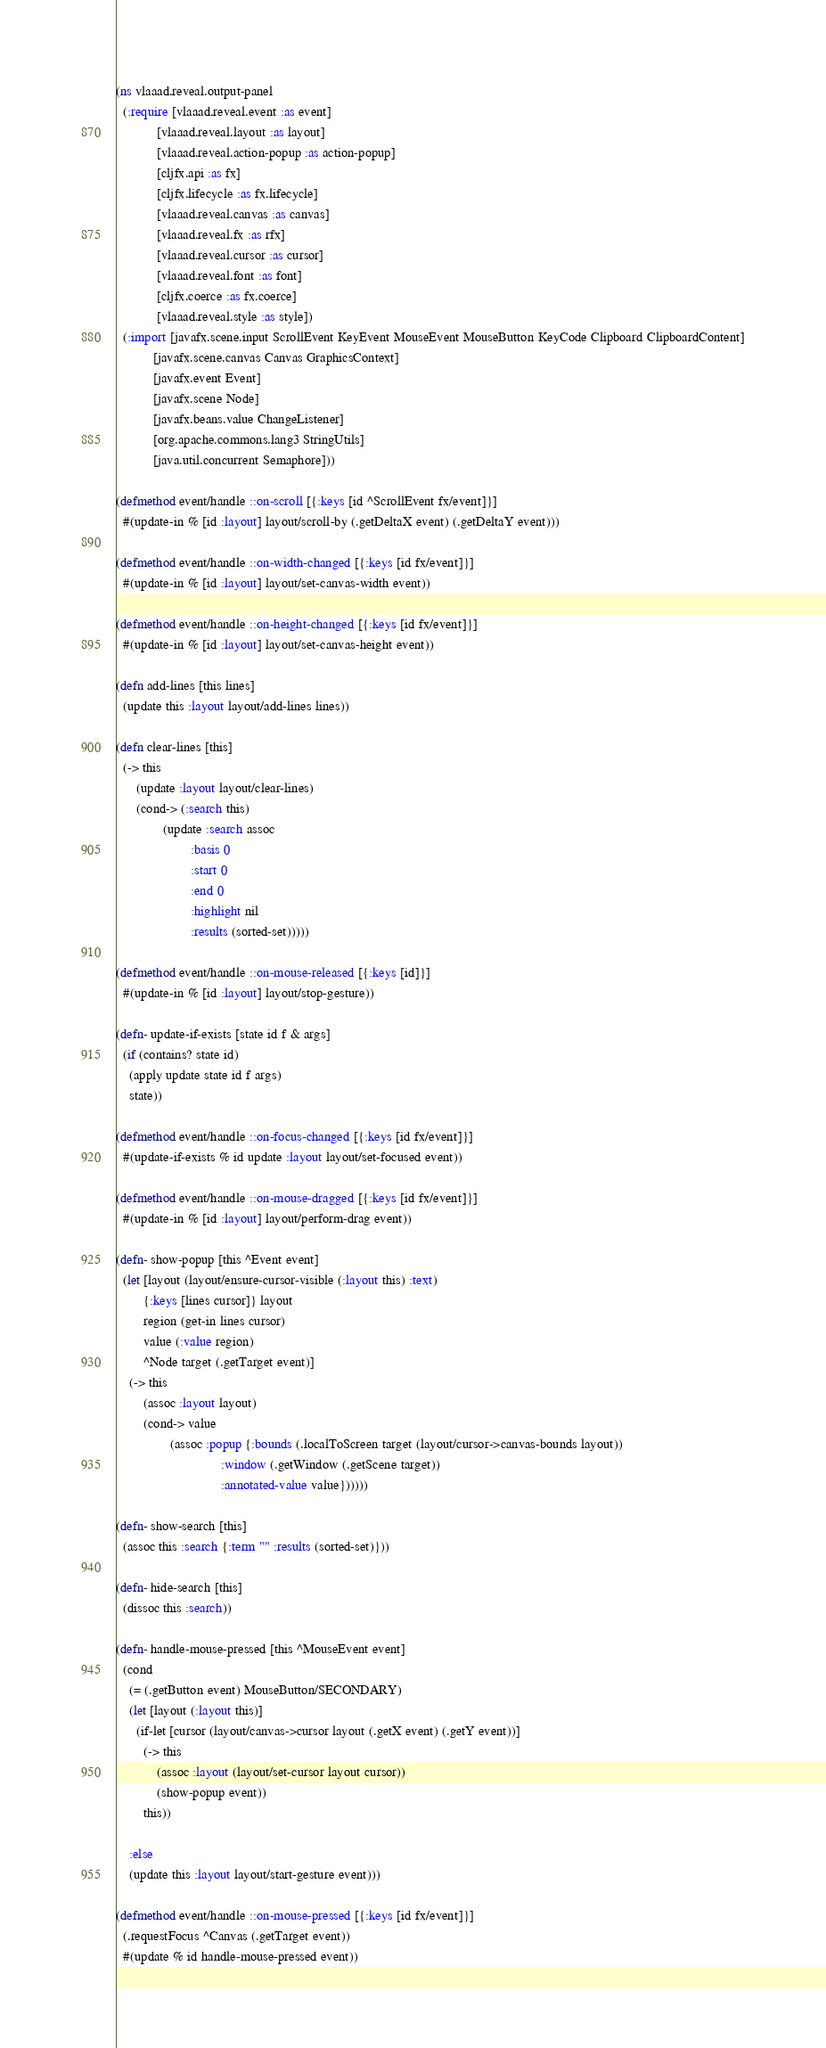Convert code to text. <code><loc_0><loc_0><loc_500><loc_500><_Clojure_>(ns vlaaad.reveal.output-panel
  (:require [vlaaad.reveal.event :as event]
            [vlaaad.reveal.layout :as layout]
            [vlaaad.reveal.action-popup :as action-popup]
            [cljfx.api :as fx]
            [cljfx.lifecycle :as fx.lifecycle]
            [vlaaad.reveal.canvas :as canvas]
            [vlaaad.reveal.fx :as rfx]
            [vlaaad.reveal.cursor :as cursor]
            [vlaaad.reveal.font :as font]
            [cljfx.coerce :as fx.coerce]
            [vlaaad.reveal.style :as style])
  (:import [javafx.scene.input ScrollEvent KeyEvent MouseEvent MouseButton KeyCode Clipboard ClipboardContent]
           [javafx.scene.canvas Canvas GraphicsContext]
           [javafx.event Event]
           [javafx.scene Node]
           [javafx.beans.value ChangeListener]
           [org.apache.commons.lang3 StringUtils]
           [java.util.concurrent Semaphore]))

(defmethod event/handle ::on-scroll [{:keys [id ^ScrollEvent fx/event]}]
  #(update-in % [id :layout] layout/scroll-by (.getDeltaX event) (.getDeltaY event)))

(defmethod event/handle ::on-width-changed [{:keys [id fx/event]}]
  #(update-in % [id :layout] layout/set-canvas-width event))

(defmethod event/handle ::on-height-changed [{:keys [id fx/event]}]
  #(update-in % [id :layout] layout/set-canvas-height event))

(defn add-lines [this lines]
  (update this :layout layout/add-lines lines))

(defn clear-lines [this]
  (-> this
      (update :layout layout/clear-lines)
      (cond-> (:search this)
              (update :search assoc
                      :basis 0
                      :start 0
                      :end 0
                      :highlight nil
                      :results (sorted-set)))))

(defmethod event/handle ::on-mouse-released [{:keys [id]}]
  #(update-in % [id :layout] layout/stop-gesture))

(defn- update-if-exists [state id f & args]
  (if (contains? state id)
    (apply update state id f args)
    state))

(defmethod event/handle ::on-focus-changed [{:keys [id fx/event]}]
  #(update-if-exists % id update :layout layout/set-focused event))

(defmethod event/handle ::on-mouse-dragged [{:keys [id fx/event]}]
  #(update-in % [id :layout] layout/perform-drag event))

(defn- show-popup [this ^Event event]
  (let [layout (layout/ensure-cursor-visible (:layout this) :text)
        {:keys [lines cursor]} layout
        region (get-in lines cursor)
        value (:value region)
        ^Node target (.getTarget event)]
    (-> this
        (assoc :layout layout)
        (cond-> value
                (assoc :popup {:bounds (.localToScreen target (layout/cursor->canvas-bounds layout))
                               :window (.getWindow (.getScene target))
                               :annotated-value value})))))

(defn- show-search [this]
  (assoc this :search {:term "" :results (sorted-set)}))

(defn- hide-search [this]
  (dissoc this :search))

(defn- handle-mouse-pressed [this ^MouseEvent event]
  (cond
    (= (.getButton event) MouseButton/SECONDARY)
    (let [layout (:layout this)]
      (if-let [cursor (layout/canvas->cursor layout (.getX event) (.getY event))]
        (-> this
            (assoc :layout (layout/set-cursor layout cursor))
            (show-popup event))
        this))

    :else
    (update this :layout layout/start-gesture event)))

(defmethod event/handle ::on-mouse-pressed [{:keys [id fx/event]}]
  (.requestFocus ^Canvas (.getTarget event))
  #(update % id handle-mouse-pressed event))
</code> 